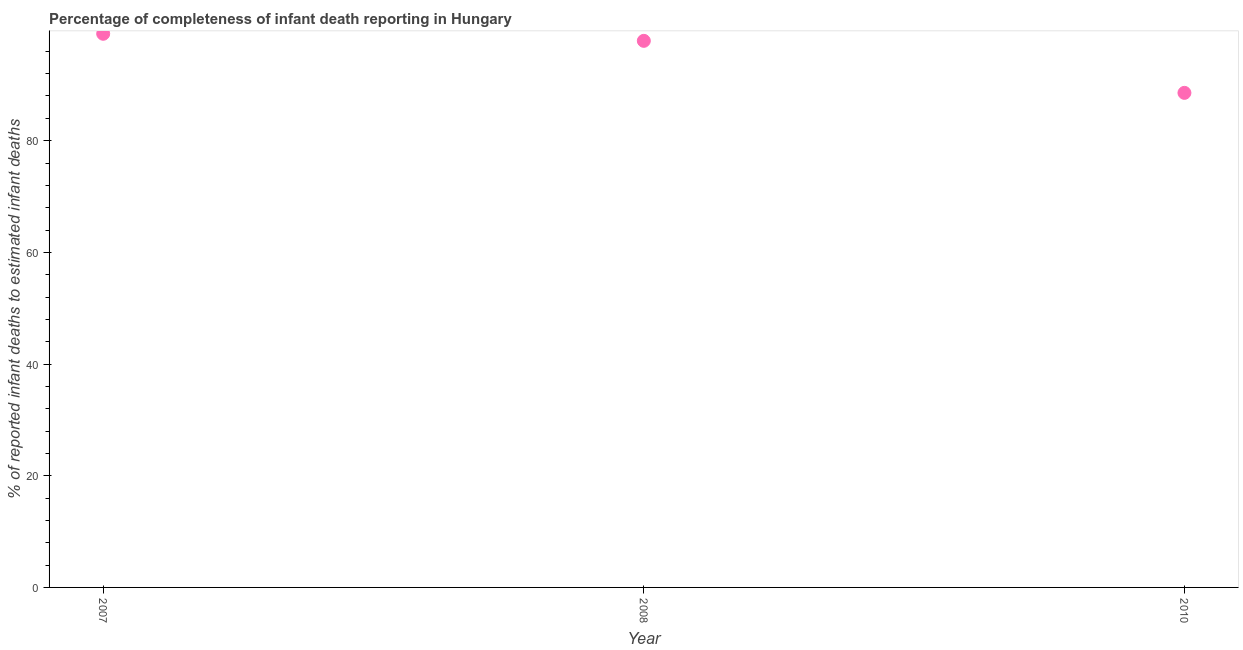What is the completeness of infant death reporting in 2010?
Provide a succinct answer. 88.56. Across all years, what is the maximum completeness of infant death reporting?
Offer a very short reply. 99.14. Across all years, what is the minimum completeness of infant death reporting?
Provide a succinct answer. 88.56. In which year was the completeness of infant death reporting maximum?
Your answer should be very brief. 2007. What is the sum of the completeness of infant death reporting?
Your answer should be very brief. 285.58. What is the difference between the completeness of infant death reporting in 2007 and 2008?
Offer a very short reply. 1.26. What is the average completeness of infant death reporting per year?
Your answer should be compact. 95.19. What is the median completeness of infant death reporting?
Give a very brief answer. 97.88. Do a majority of the years between 2010 and 2008 (inclusive) have completeness of infant death reporting greater than 92 %?
Offer a terse response. No. What is the ratio of the completeness of infant death reporting in 2007 to that in 2010?
Your response must be concise. 1.12. Is the completeness of infant death reporting in 2008 less than that in 2010?
Your answer should be very brief. No. Is the difference between the completeness of infant death reporting in 2007 and 2008 greater than the difference between any two years?
Keep it short and to the point. No. What is the difference between the highest and the second highest completeness of infant death reporting?
Provide a succinct answer. 1.26. What is the difference between the highest and the lowest completeness of infant death reporting?
Ensure brevity in your answer.  10.58. In how many years, is the completeness of infant death reporting greater than the average completeness of infant death reporting taken over all years?
Offer a terse response. 2. Does the completeness of infant death reporting monotonically increase over the years?
Provide a short and direct response. No. How many dotlines are there?
Ensure brevity in your answer.  1. How many years are there in the graph?
Provide a succinct answer. 3. Does the graph contain any zero values?
Offer a terse response. No. What is the title of the graph?
Offer a terse response. Percentage of completeness of infant death reporting in Hungary. What is the label or title of the X-axis?
Give a very brief answer. Year. What is the label or title of the Y-axis?
Provide a short and direct response. % of reported infant deaths to estimated infant deaths. What is the % of reported infant deaths to estimated infant deaths in 2007?
Provide a succinct answer. 99.14. What is the % of reported infant deaths to estimated infant deaths in 2008?
Give a very brief answer. 97.88. What is the % of reported infant deaths to estimated infant deaths in 2010?
Keep it short and to the point. 88.56. What is the difference between the % of reported infant deaths to estimated infant deaths in 2007 and 2008?
Provide a succinct answer. 1.26. What is the difference between the % of reported infant deaths to estimated infant deaths in 2007 and 2010?
Offer a very short reply. 10.58. What is the difference between the % of reported infant deaths to estimated infant deaths in 2008 and 2010?
Make the answer very short. 9.32. What is the ratio of the % of reported infant deaths to estimated infant deaths in 2007 to that in 2008?
Provide a short and direct response. 1.01. What is the ratio of the % of reported infant deaths to estimated infant deaths in 2007 to that in 2010?
Make the answer very short. 1.12. What is the ratio of the % of reported infant deaths to estimated infant deaths in 2008 to that in 2010?
Your response must be concise. 1.1. 